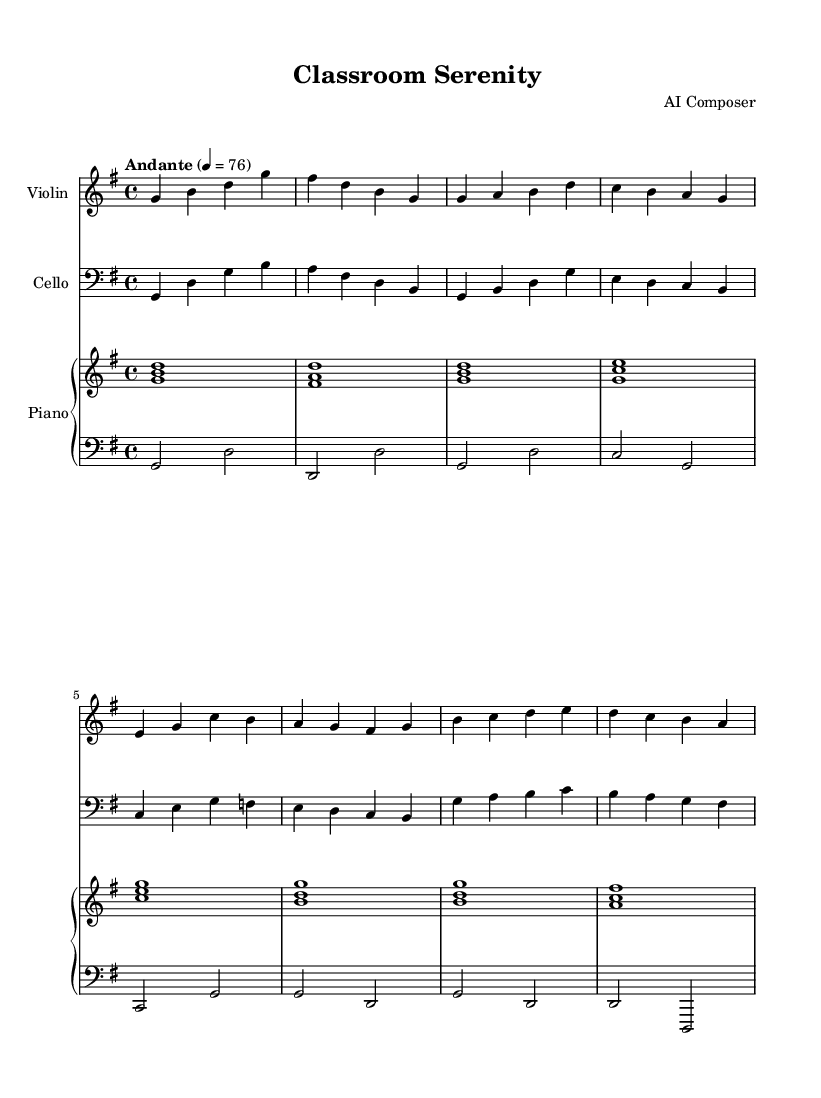What is the key signature of this music? The key signature is defined by the sharp or flat symbols in the staff. In this sheet music, there are no sharps or flats indicated, so the key is G major, which has one sharp.
Answer: G major What is the time signature of this piece? The time signature is indicated at the beginning of the piece as a fraction, with the top number representing the beats per measure and the bottom number indicating the note value. Here, the time signature is 4/4, which means there are four beats in each measure, and the quarter note gets one beat.
Answer: 4/4 What is the tempo marking for the piece? The tempo marking appears near the beginning of the score. It is labeled as "Andante" with a metronome marking of 76 beats per minute, indicating a moderately slow tempo.
Answer: Andante, 76 How many measures are there in the A section? To find the number of measures in the A section, we can count the measures specifically designated for this section in the sheet music. The A section is made up of four measures, as indicated in the note pattern.
Answer: 4 Which instruments are included in this composition? The instruments are listed at the beginning of the score. Three staves indicate the presence of violin, cello, and piano, confirming that these are the instruments involved in the piece.
Answer: Violin, Cello, Piano What type of music is "Classroom Serenity"? The title at the beginning of the sheet music suggests the purpose and mood of the piece. Given the title and the soft, calming characteristics of the music, it is categorized as calming instrumental music suitable for classroom ambiance.
Answer: Calming instrumental music 